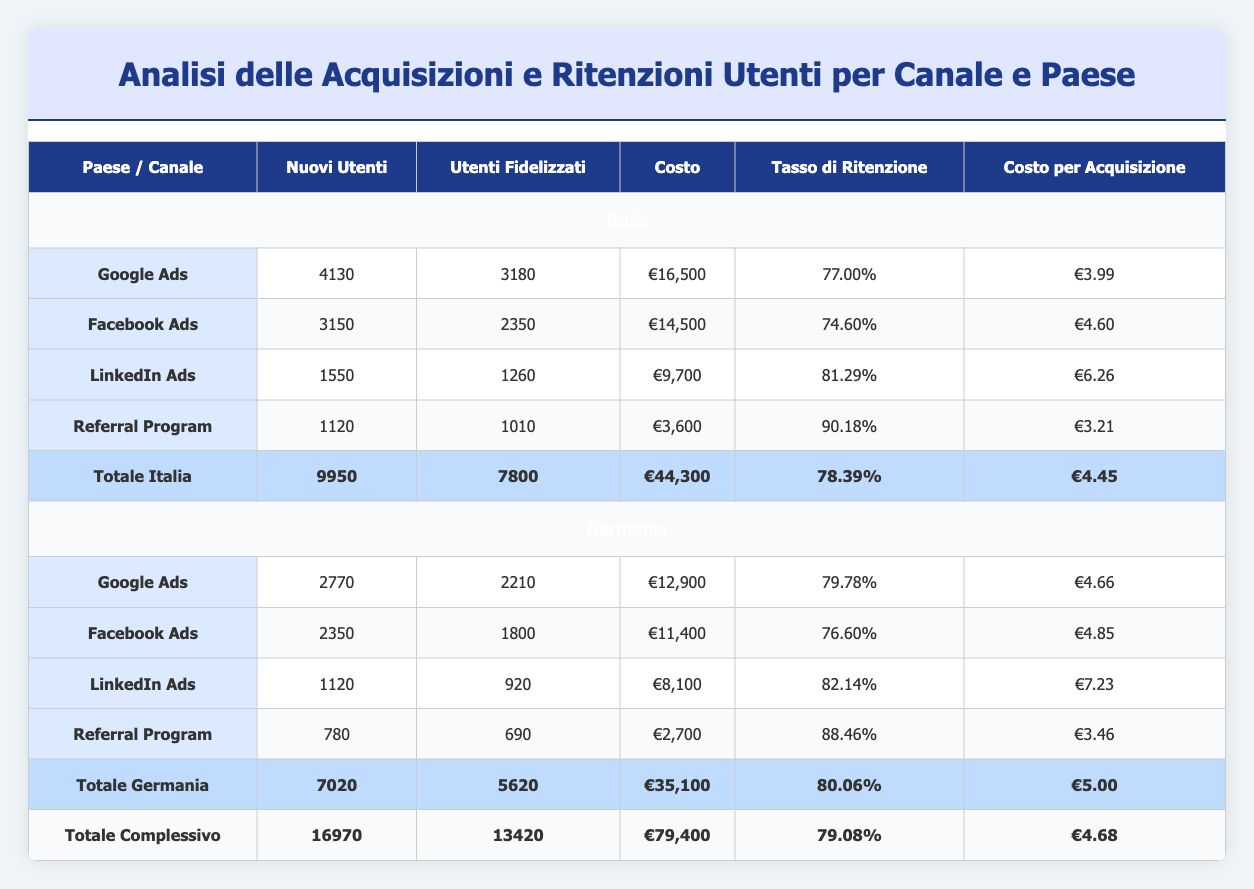What is the total new user count for Italy? To find the total new user count for Italy, we need to sum the new users from all channels for Italy. The values are: Google Ads (4130), Facebook Ads (3150), LinkedIn Ads (1550), and Referral Program (1120). Adding these together gives: 4130 + 3150 + 1550 + 1120 = 9950.
Answer: 9950 Which channel has the highest retention rate in Germany? Looking at the retention rates for Germany, we have: Google Ads (79.78%), Facebook Ads (76.60%), LinkedIn Ads (82.14%), and Referral Program (88.46%). The highest value is from the Referral Program, which is 88.46%.
Answer: Referral Program What is the total cost for all marketing channels in Italy? The total cost is calculated by summing the costs for each channel in Italy: Google Ads (€16,500), Facebook Ads (€14,500), LinkedIn Ads (€9,700), and Referral Program (€3,600). Adding these amounts gives: 16500 + 14500 + 9700 + 3600 = 44300.
Answer: €44,300 Is the average cost per acquisition for Italian users higher than in Germany? The average cost per acquisition for Italy is calculated as total cost (€44,300) divided by total new users (9950), which equals €4.45. For Germany, total cost is €35,100 and total new users is 7020, resulting in €5.00. Since €4.45 < €5.00, the average cost is lower in Italy.
Answer: No What is the overall retention rate across all channels and countries? To find the overall retention rate, we need to calculate the total retained users (7800 for Italy and 5620 for Germany), which sums up to 13420. We also need the total new users (16970). The retention rate is calculated as (Total Retained Users / Total New Users) * 100 = (13420 / 16970) * 100, which gives approximately 79.08%.
Answer: 79.08% Which month had the highest new user acquisition through Facebook Ads? By comparing the new users acquired through Facebook Ads across all months, we have: January (980), February (1050), and March (1120). The highest number is from March, which is 1120.
Answer: March How much did each channel cost per retained user in Italy? To find the cost per retained user for each channel in Italy, we divide the total cost by the retained users: Google Ads (€16,500 / 3180) = €5.19, Facebook Ads (€14,500 / 2350) = €6.17, LinkedIn Ads (€9,700 / 1260) = €7.70, and Referral Program (€3,600 / 1010) = €3.57. The lowest cost per retained user is from the Referral Program at €3.57.
Answer: €3.57 Which channel generated the most new users in Germany during February? In February, the new user counts for Germany by channel are: Google Ads (920), Facebook Ads (780), LinkedIn Ads (380), and Referral Program (260). The highest new user count comes from Google Ads, with 920 new users.
Answer: Google Ads What percentage of new users from LinkedIn Ads were retained in Italy? To find the retention percentage for LinkedIn Ads in Italy, we take the retained users (1260) and divide by the new users (1550), then multiply by 100. So, (1260 / 1550) * 100 = approximately 81.29%.
Answer: 81.29% 